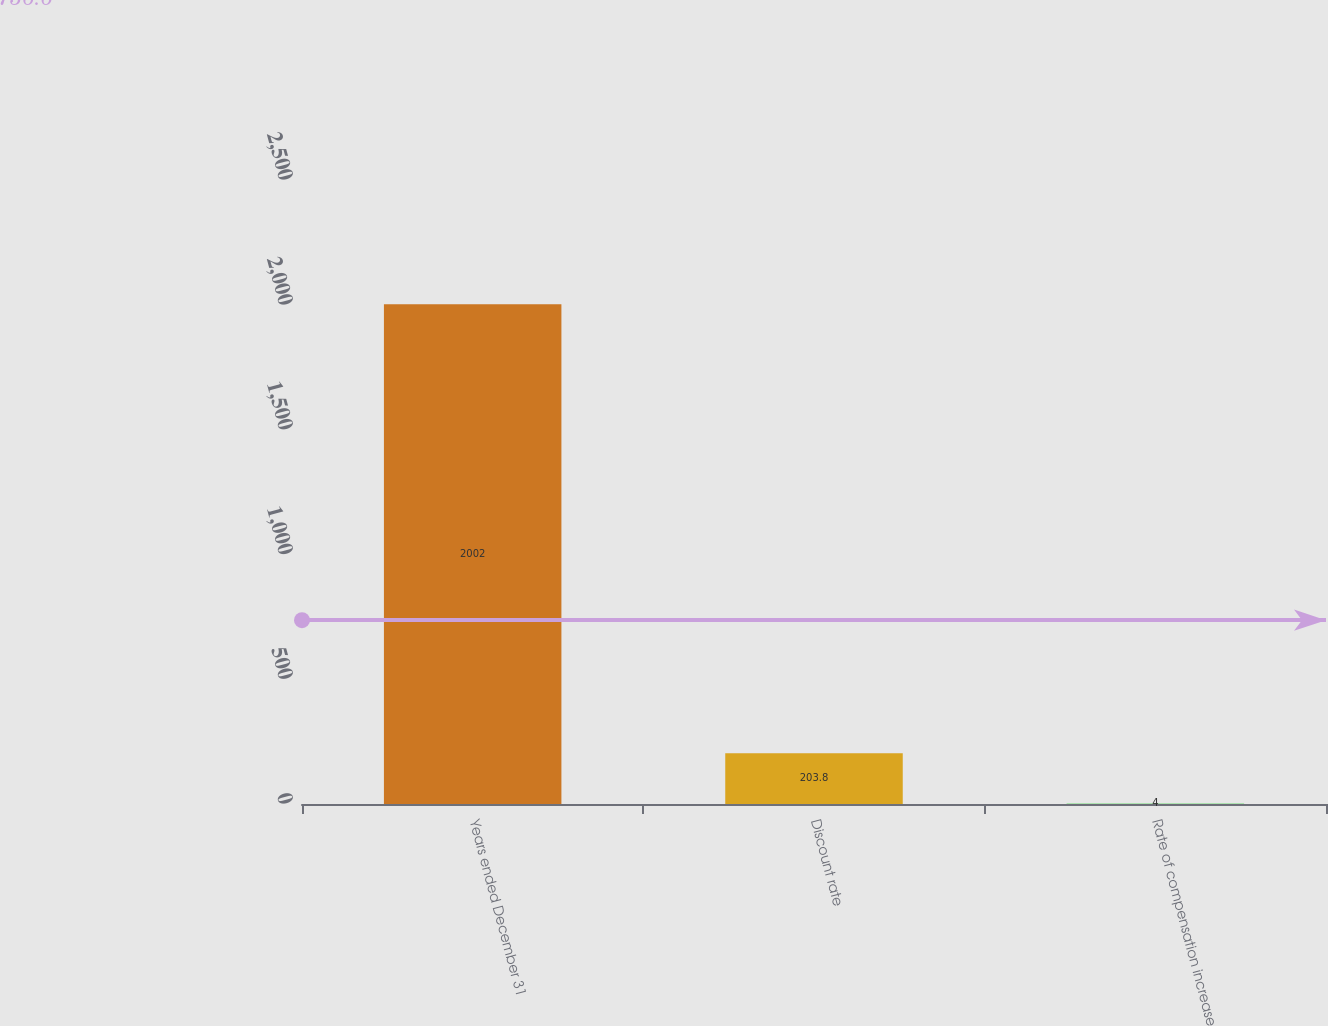<chart> <loc_0><loc_0><loc_500><loc_500><bar_chart><fcel>Years ended December 31<fcel>Discount rate<fcel>Rate of compensation increase<nl><fcel>2002<fcel>203.8<fcel>4<nl></chart> 